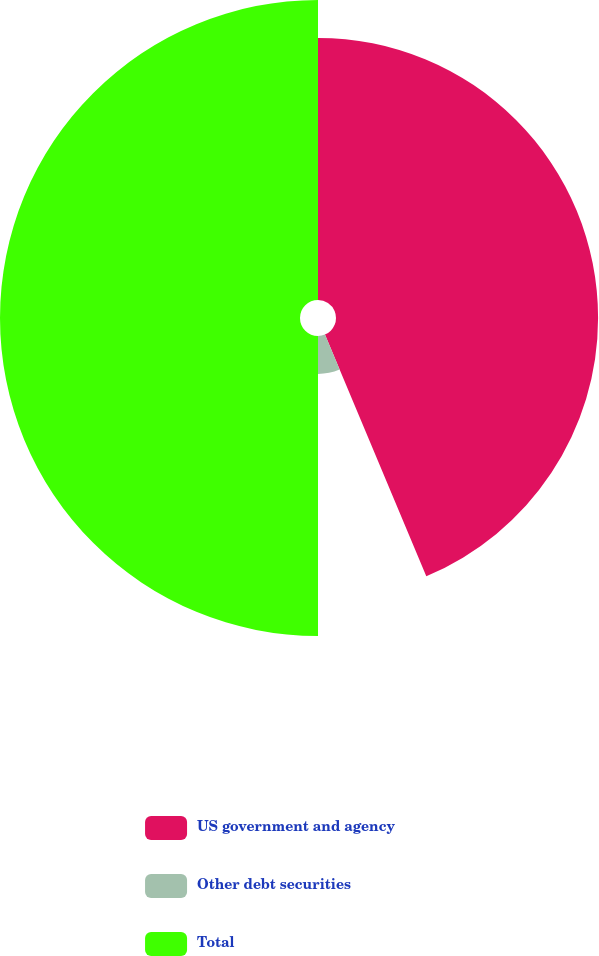Convert chart to OTSL. <chart><loc_0><loc_0><loc_500><loc_500><pie_chart><fcel>US government and agency<fcel>Other debt securities<fcel>Total<nl><fcel>43.68%<fcel>6.32%<fcel>50.0%<nl></chart> 